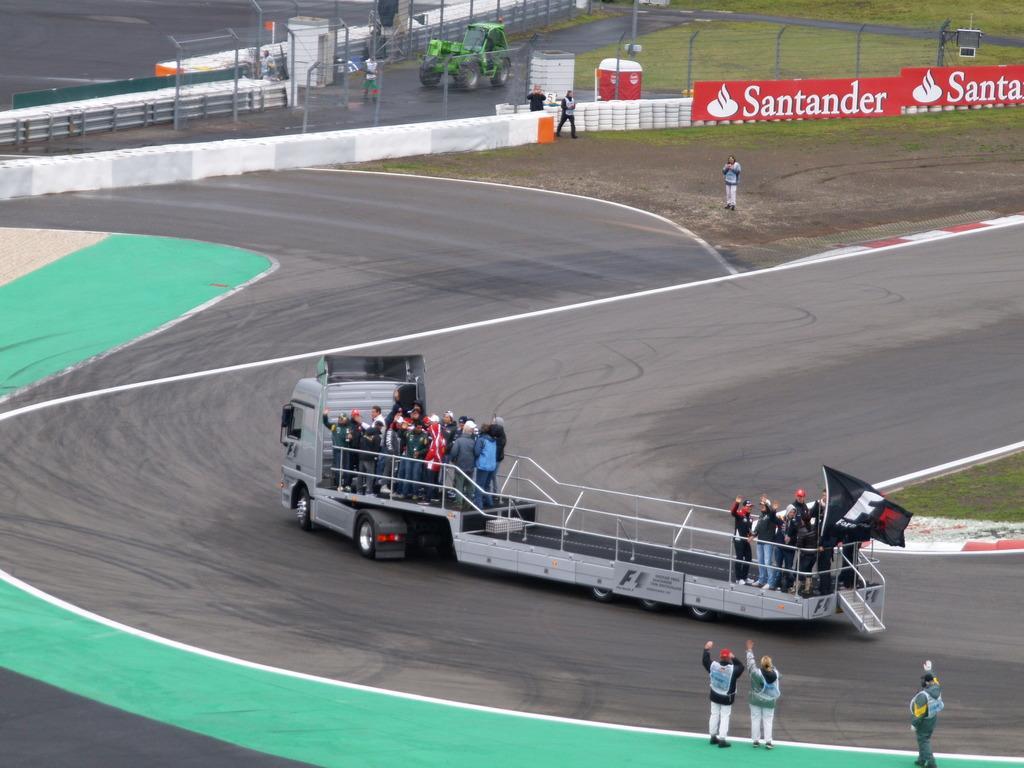How would you summarize this image in a sentence or two? In this image I can see the vehicle and I can see group of people standing in the vehicles. Background I can see few other persons standing, few banners in red color and I can also see few poles. 